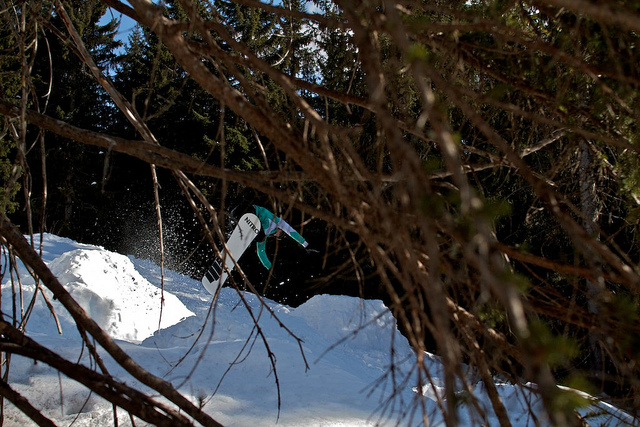<image>Did he fall? I don't know if he fell. Some answers suggest yes, but it's not entirely certain. Did he fall? I don't know if he fell. It is possible that he fell based on the answers given. 